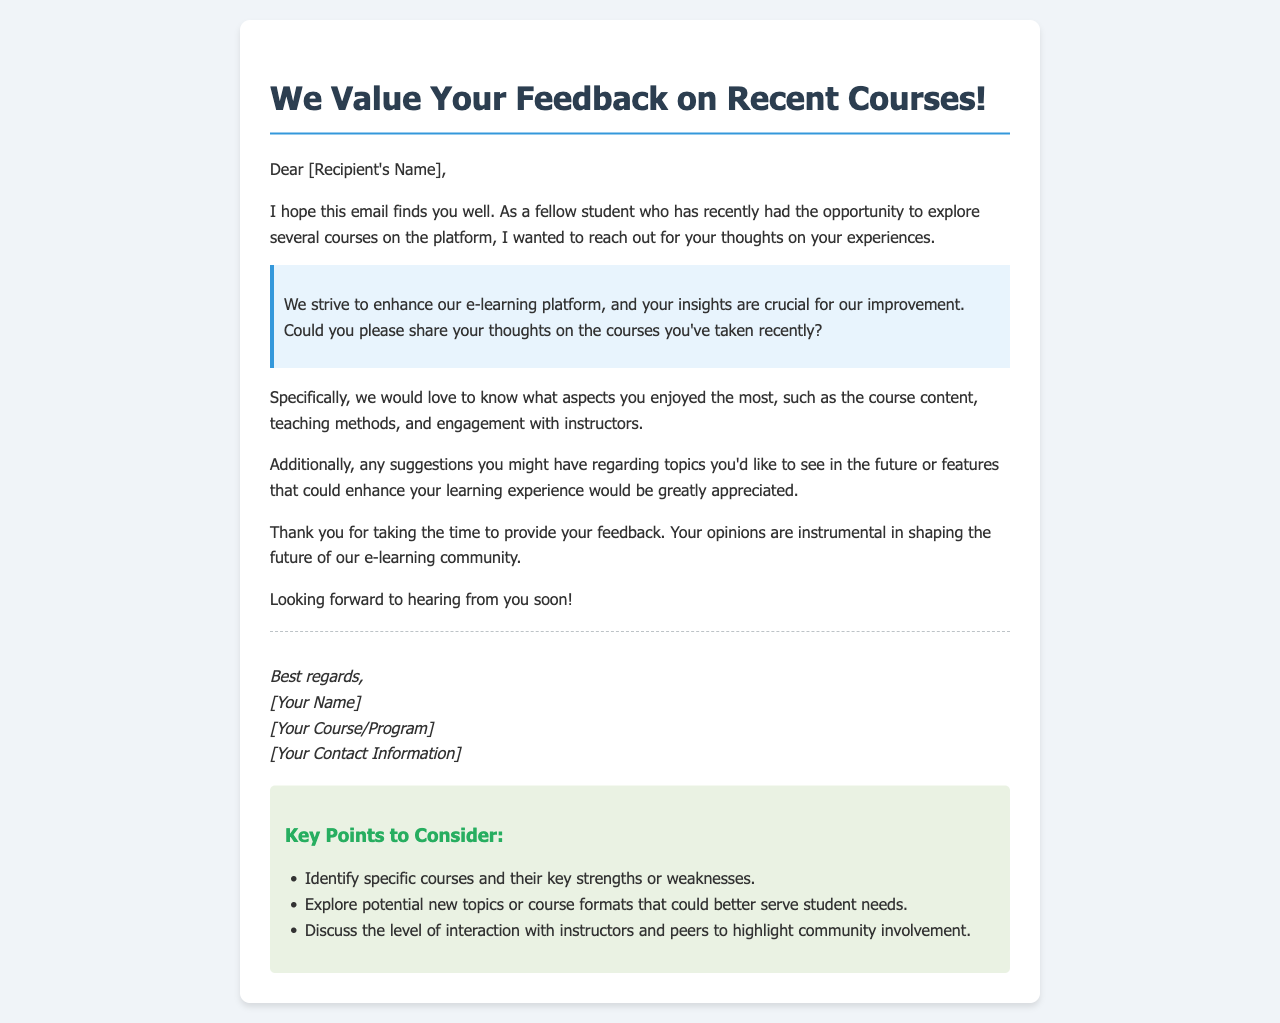What is the main purpose of the email? The main purpose of the email is to request feedback from the recipient regarding their experiences with recent courses.
Answer: Request feedback Who is the email addressed to? The email is addressed to "[Recipient's Name]," indicating a personalized approach to feedback collection.
Answer: [Recipient's Name] What should recipients share about their course experiences? Recipients are encouraged to share their thoughts on aspects like course content, teaching methods, and engagement with instructors.
Answer: Course content, teaching methods, engagement What type of suggestions are being requested? The email requests suggestions for future topics or features that could enhance learning experiences.
Answer: Topics or features What is one of the key points to consider when providing feedback? One key point to consider is identifying specific courses and their key strengths or weaknesses.
Answer: Identify specific courses What greeting is used in the email? The greeting used is "Dear [Recipient's Name]," which establishes a friendly tone.
Answer: Dear [Recipient's Name] Who is sending the email? The email is signed off by "[Your Name]," indicating the sender is a fellow student involved in the course.
Answer: [Your Name] What formatting is used in the key points section? The key points section is formatted with a heading and an unordered list for clarity.
Answer: Heading and unordered list 